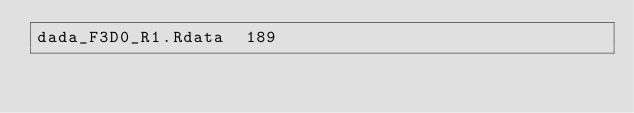<code> <loc_0><loc_0><loc_500><loc_500><_SQL_>dada_F3D0_R1.Rdata	189
</code> 